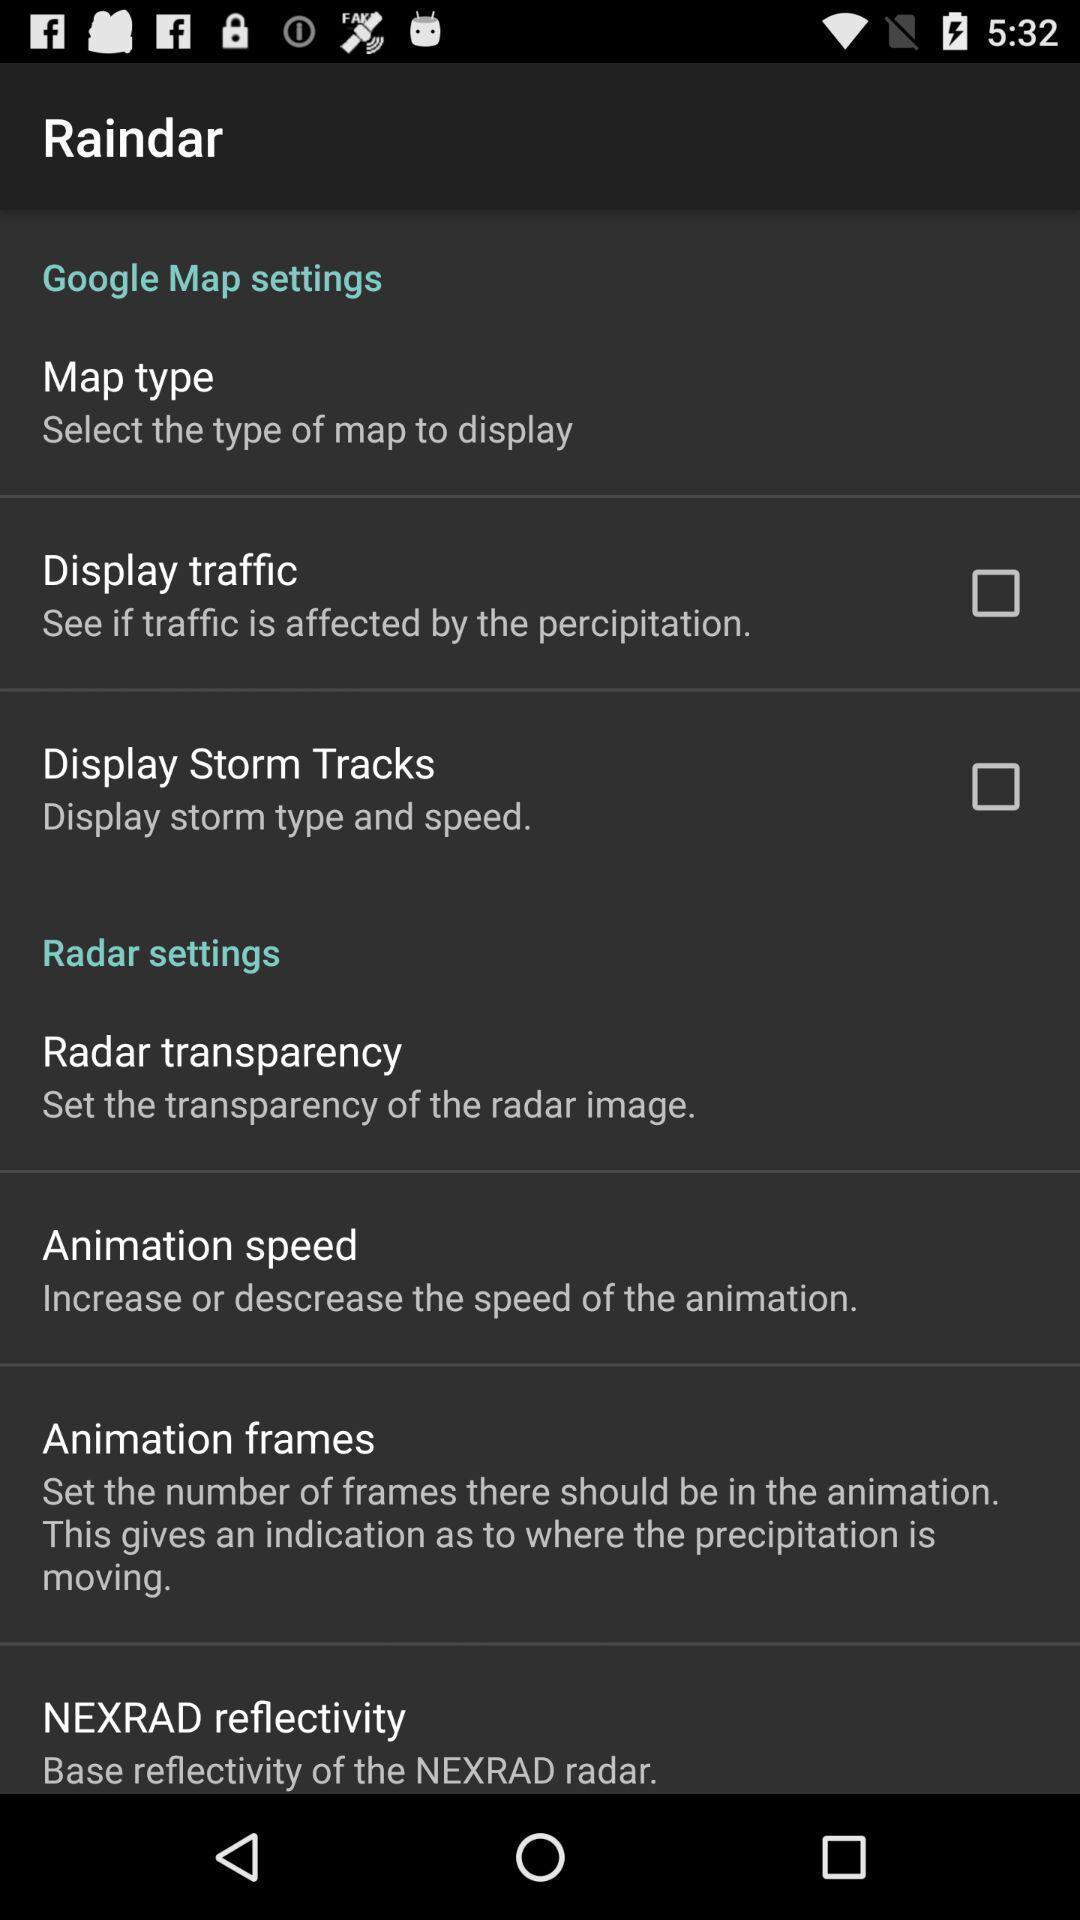What is the overall content of this screenshot? Screen shows multiple options for mapping application. 